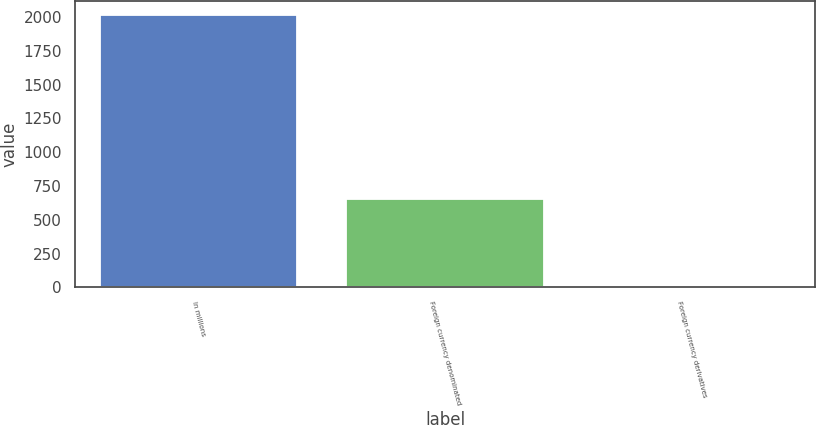<chart> <loc_0><loc_0><loc_500><loc_500><bar_chart><fcel>In millions<fcel>Foreign currency denominated<fcel>Foreign currency derivatives<nl><fcel>2016<fcel>654.9<fcel>9.9<nl></chart> 